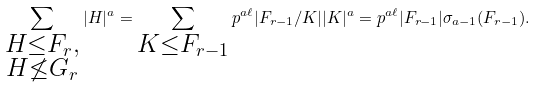Convert formula to latex. <formula><loc_0><loc_0><loc_500><loc_500>\sum _ { \substack { H \leq F _ { r } , \\ H \not \leq G _ { r } } } | H | ^ { a } = \sum _ { \substack { K \leq F _ { r - 1 } } } p ^ { a \ell } | F _ { r - 1 } / K | | K | ^ { a } = p ^ { a \ell } | F _ { r - 1 } | \sigma _ { a - 1 } ( F _ { r - 1 } ) .</formula> 